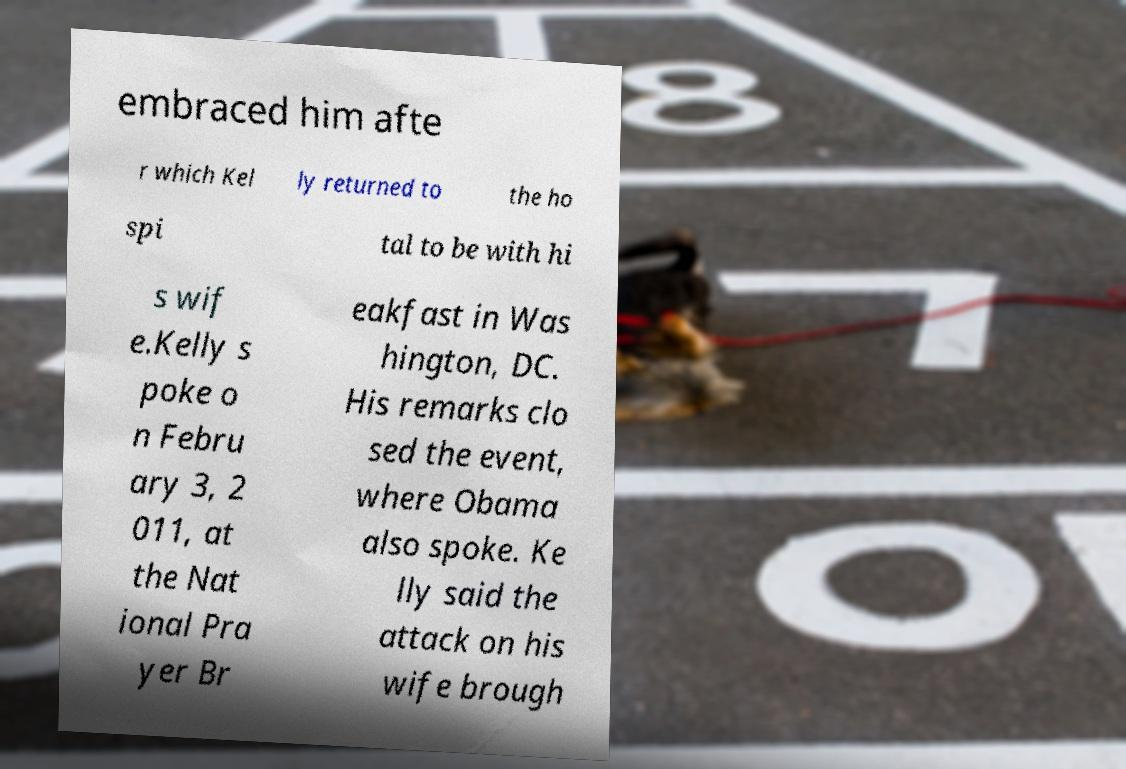There's text embedded in this image that I need extracted. Can you transcribe it verbatim? embraced him afte r which Kel ly returned to the ho spi tal to be with hi s wif e.Kelly s poke o n Febru ary 3, 2 011, at the Nat ional Pra yer Br eakfast in Was hington, DC. His remarks clo sed the event, where Obama also spoke. Ke lly said the attack on his wife brough 